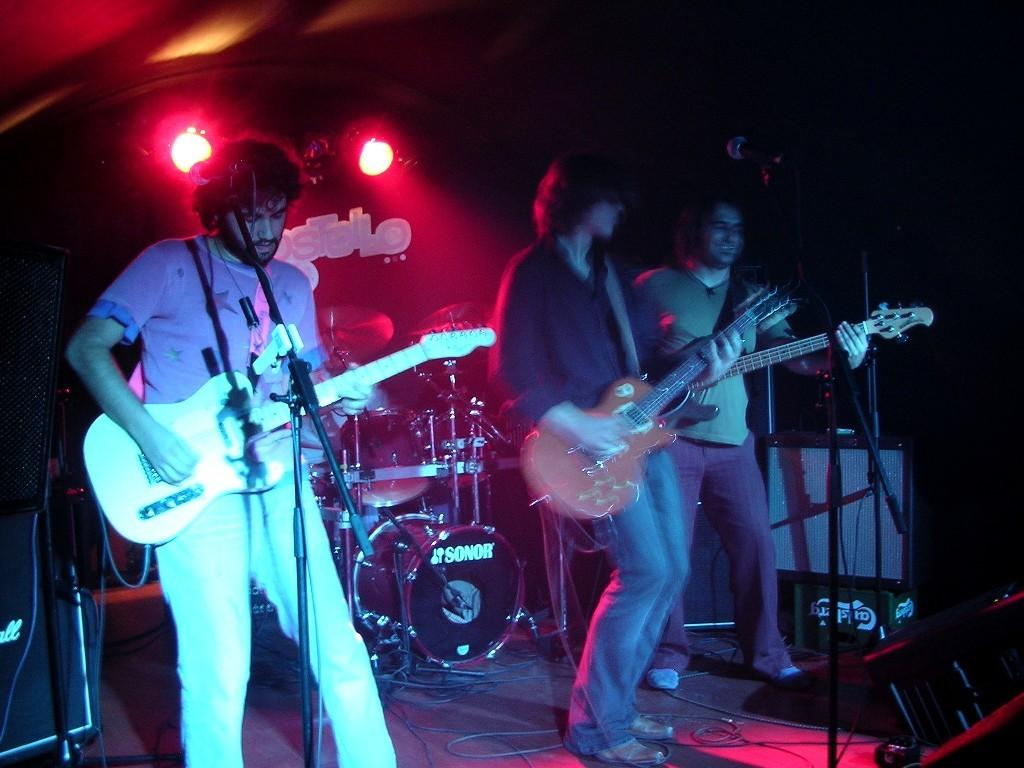How many people are in the image? There are three people in the image. Where are the people located in the image? The people are standing on a stage. What are the people doing in the image? The people are playing guitars. What other musical instrument can be seen in the background? There is an electronic drum in the background. What type of cave can be seen in the background of the image? There is no cave present in the image; it features a stage with people playing guitars and an electronic drum in the background. 